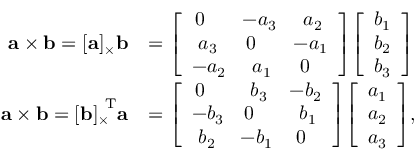Convert formula to latex. <formula><loc_0><loc_0><loc_500><loc_500>{ \begin{array} { r l } { a \times b = [ a ] _ { \times } b } & { = { \left [ \begin{array} { l l l } { \, 0 } & { \, - a _ { 3 } } & { \, a _ { 2 } } \\ { \, a _ { 3 } } & { 0 } & { \, - a _ { 1 } } \\ { - a _ { 2 } } & { \, a _ { 1 } } & { \, 0 } \end{array} \right ] } { \left [ \begin{array} { l } { b _ { 1 } } \\ { b _ { 2 } } \\ { b _ { 3 } } \end{array} \right ] } } \\ { a \times b = { [ b ] _ { \times } } ^ { \, T } a } & { = { \left [ \begin{array} { l l l } { \, 0 } & { \, b _ { 3 } } & { \, - b _ { 2 } } \\ { - b _ { 3 } } & { 0 } & { \, b _ { 1 } } \\ { \, b _ { 2 } } & { \, - b _ { 1 } } & { \, 0 } \end{array} \right ] } { \left [ \begin{array} { l } { a _ { 1 } } \\ { a _ { 2 } } \\ { a _ { 3 } } \end{array} \right ] } , } \end{array} }</formula> 